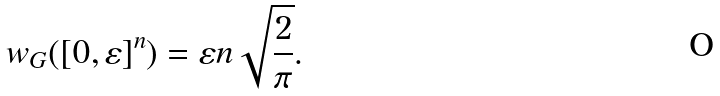Convert formula to latex. <formula><loc_0><loc_0><loc_500><loc_500>w _ { G } ( [ 0 , \varepsilon ] ^ { n } ) = \varepsilon n \sqrt { \frac { 2 } { \pi } } .</formula> 